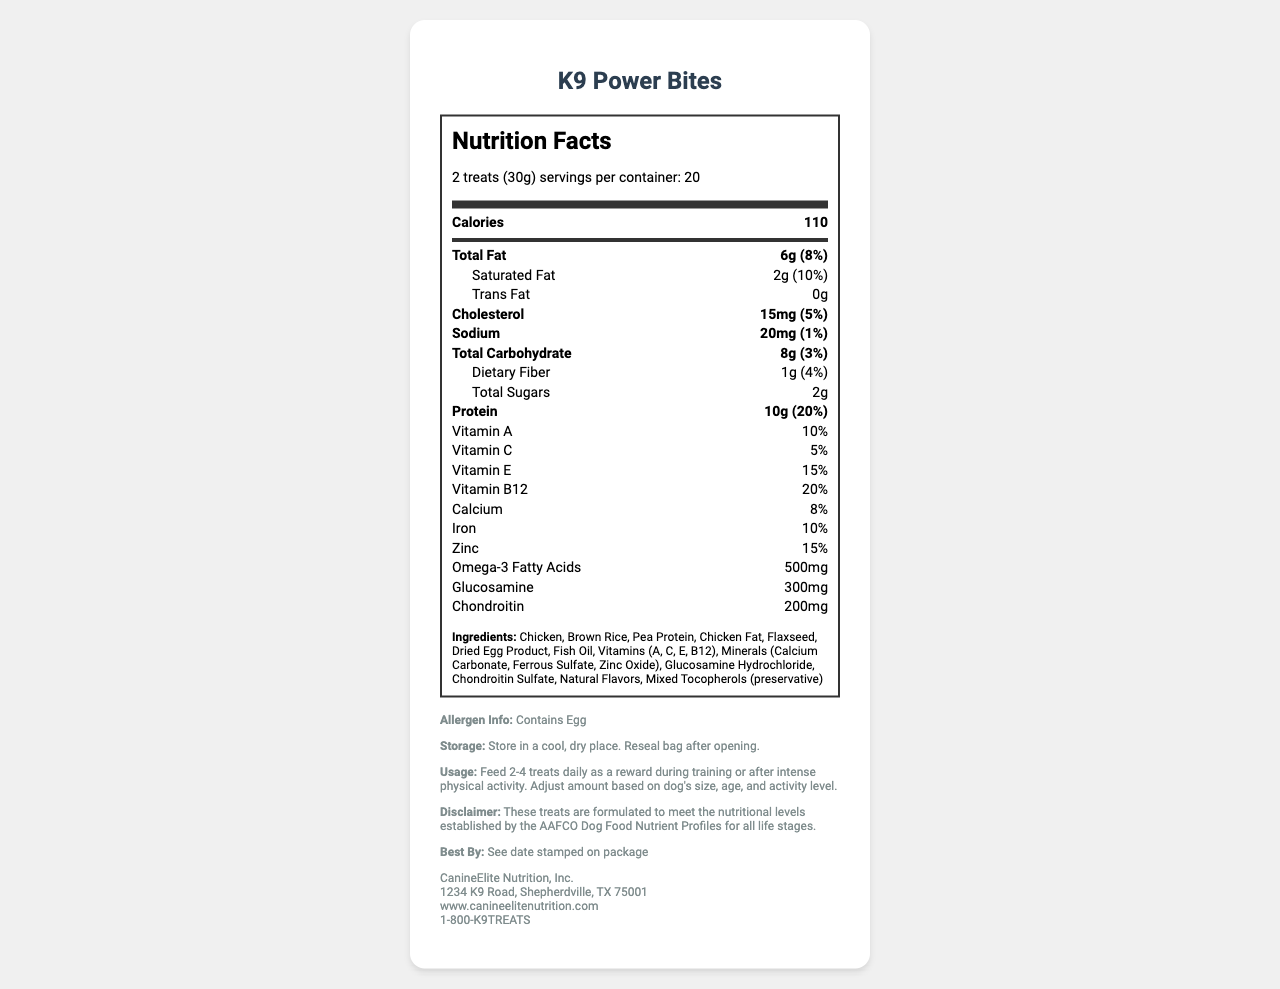what is the serving size of K9 Power Bites? The serving size is specified in the document as "2 treats (30g)".
Answer: 2 treats (30g) how many servings are there in one container? The document mentions that there are 20 servings per container.
Answer: 20 what is the amount of protein in one serving? The protein amount per serving is listed as 10g in the document.
Answer: 10g how much total fat is in one serving? The total fat per serving is shown as 6g in the document.
Answer: 6g what vitamins are included in the K9 Power Bites? The document lists vitamins A, C, E, and B12 under the vitamins section.
Answer: A, C, E, B12 what is the daily value percentage of Vitamin E per serving? The daily value percentage of Vitamin E per serving is listed as 15% in the document.
Answer: 15% what ingredient contains an allergen? The document specifies "Contains Egg" in the allergen information.
Answer: Egg what is the total carbohydrate content? A. 6g B. 8g C. 10g D. 12g The total carbohydrate content per serving is listed as 8g in the document.
Answer: B which of the following minerals is not listed in the ingredients? I. Calcium II. Iron III. Magnesium IV. Zinc Magnesium is not listed among the minerals in the ingredients section of the document.
Answer: III is fish oil included in the ingredients? Fish oil is mentioned as one of the ingredients in the document.
Answer: Yes what is the purpose of these treats? The document states that the treats are intended to be fed as a reward during training or after intense physical activity.
Answer: To reward K9s during training or after intense physical activity what company manufactures K9 Power Bites? The manufacturer is listed as CanineElite Nutrition, Inc.
Answer: CanineElite Nutrition, Inc. what kind of bag should this product be stored in? The storage instructions advise resealing the bag after opening.
Answer: Reseal bag after opening are there any trans fats in K9 Power Bites? The document states that the amount of trans fats per serving is 0g.
Answer: No does the product address the nutritional levels established by the AAFCO Dog Food Nutrient Profiles? The disclaimer indicates that the treats are formulated to meet the AAFCO Dog Food Nutrient Profiles for all life stages.
Answer: Yes summarize the document. The summary encapsulates the main points of the document, including nutritional details, ingredients, usage instructions, and manufacturer information.
Answer: The document provides detailed nutrition facts for K9 Power Bites, a performance-enhancing dog treat designed for police and military K9 units. It lists serving size, servings per container, calorie count, and nutrient information including various vitamins and minerals. It also includes ingredient details, allergen info, storage instructions, usage recommendations, and manufacturer information. how many grams of trans fat are in each serving of K9 Power Bites? The document clearly lists the trans fat content as 0g per serving.
Answer: 0g 